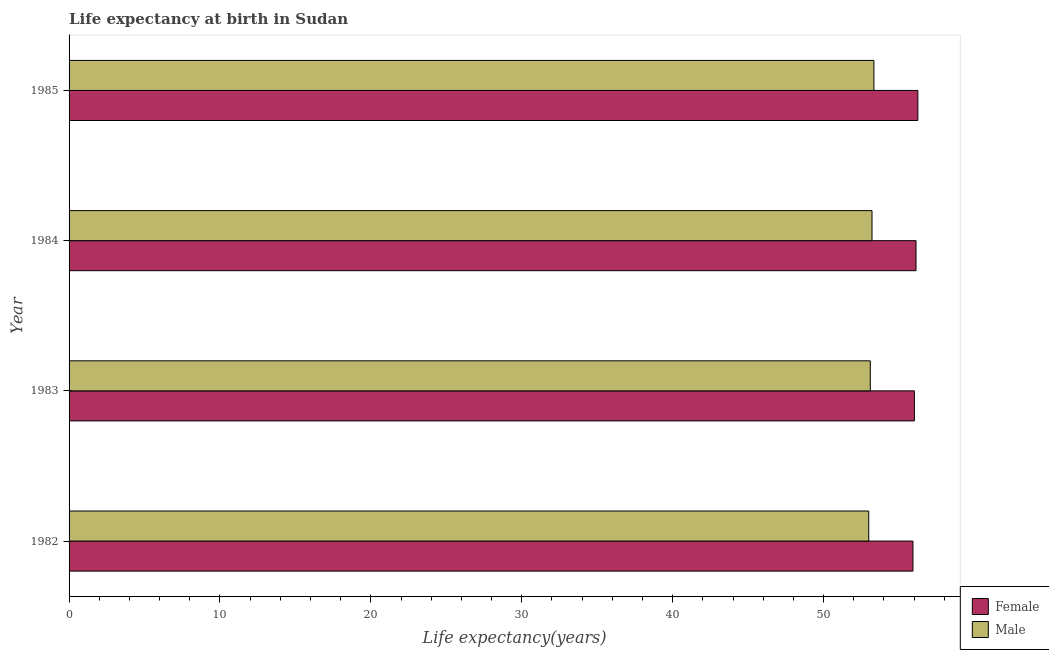Are the number of bars per tick equal to the number of legend labels?
Give a very brief answer. Yes. Are the number of bars on each tick of the Y-axis equal?
Provide a succinct answer. Yes. How many bars are there on the 3rd tick from the bottom?
Your response must be concise. 2. What is the life expectancy(female) in 1985?
Your response must be concise. 56.25. Across all years, what is the maximum life expectancy(male)?
Offer a very short reply. 53.34. Across all years, what is the minimum life expectancy(male)?
Offer a very short reply. 53. What is the total life expectancy(male) in the graph?
Offer a very short reply. 212.65. What is the difference between the life expectancy(male) in 1982 and that in 1985?
Provide a succinct answer. -0.34. What is the difference between the life expectancy(male) in 1985 and the life expectancy(female) in 1982?
Your answer should be compact. -2.59. What is the average life expectancy(male) per year?
Your answer should be compact. 53.16. In the year 1985, what is the difference between the life expectancy(female) and life expectancy(male)?
Your response must be concise. 2.91. What is the ratio of the life expectancy(male) in 1984 to that in 1985?
Give a very brief answer. 1. Is the life expectancy(male) in 1982 less than that in 1983?
Ensure brevity in your answer.  Yes. What is the difference between the highest and the lowest life expectancy(male)?
Give a very brief answer. 0.34. In how many years, is the life expectancy(female) greater than the average life expectancy(female) taken over all years?
Give a very brief answer. 2. What does the 2nd bar from the bottom in 1982 represents?
Keep it short and to the point. Male. Are all the bars in the graph horizontal?
Keep it short and to the point. Yes. How many years are there in the graph?
Offer a very short reply. 4. What is the difference between two consecutive major ticks on the X-axis?
Provide a succinct answer. 10. Are the values on the major ticks of X-axis written in scientific E-notation?
Offer a very short reply. No. Does the graph contain any zero values?
Provide a succinct answer. No. How are the legend labels stacked?
Offer a very short reply. Vertical. What is the title of the graph?
Ensure brevity in your answer.  Life expectancy at birth in Sudan. What is the label or title of the X-axis?
Ensure brevity in your answer.  Life expectancy(years). What is the label or title of the Y-axis?
Offer a terse response. Year. What is the Life expectancy(years) of Female in 1982?
Your answer should be compact. 55.92. What is the Life expectancy(years) in Male in 1982?
Your answer should be very brief. 53. What is the Life expectancy(years) in Female in 1983?
Keep it short and to the point. 56.02. What is the Life expectancy(years) in Male in 1983?
Keep it short and to the point. 53.1. What is the Life expectancy(years) of Female in 1984?
Ensure brevity in your answer.  56.13. What is the Life expectancy(years) in Male in 1984?
Keep it short and to the point. 53.21. What is the Life expectancy(years) in Female in 1985?
Your response must be concise. 56.25. What is the Life expectancy(years) of Male in 1985?
Give a very brief answer. 53.34. Across all years, what is the maximum Life expectancy(years) of Female?
Make the answer very short. 56.25. Across all years, what is the maximum Life expectancy(years) of Male?
Your response must be concise. 53.34. Across all years, what is the minimum Life expectancy(years) of Female?
Offer a terse response. 55.92. Across all years, what is the minimum Life expectancy(years) of Male?
Your answer should be compact. 53. What is the total Life expectancy(years) in Female in the graph?
Ensure brevity in your answer.  224.33. What is the total Life expectancy(years) in Male in the graph?
Your response must be concise. 212.65. What is the difference between the Life expectancy(years) of Female in 1982 and that in 1983?
Your answer should be compact. -0.1. What is the difference between the Life expectancy(years) in Male in 1982 and that in 1983?
Provide a succinct answer. -0.1. What is the difference between the Life expectancy(years) of Female in 1982 and that in 1984?
Give a very brief answer. -0.2. What is the difference between the Life expectancy(years) in Male in 1982 and that in 1984?
Your answer should be very brief. -0.22. What is the difference between the Life expectancy(years) in Female in 1982 and that in 1985?
Make the answer very short. -0.33. What is the difference between the Life expectancy(years) of Male in 1982 and that in 1985?
Offer a very short reply. -0.34. What is the difference between the Life expectancy(years) in Female in 1983 and that in 1984?
Your answer should be compact. -0.11. What is the difference between the Life expectancy(years) of Male in 1983 and that in 1984?
Your response must be concise. -0.11. What is the difference between the Life expectancy(years) in Female in 1983 and that in 1985?
Your answer should be very brief. -0.23. What is the difference between the Life expectancy(years) in Male in 1983 and that in 1985?
Provide a short and direct response. -0.24. What is the difference between the Life expectancy(years) of Female in 1984 and that in 1985?
Give a very brief answer. -0.12. What is the difference between the Life expectancy(years) of Male in 1984 and that in 1985?
Your response must be concise. -0.12. What is the difference between the Life expectancy(years) in Female in 1982 and the Life expectancy(years) in Male in 1983?
Provide a succinct answer. 2.83. What is the difference between the Life expectancy(years) in Female in 1982 and the Life expectancy(years) in Male in 1984?
Give a very brief answer. 2.71. What is the difference between the Life expectancy(years) of Female in 1982 and the Life expectancy(years) of Male in 1985?
Your answer should be compact. 2.59. What is the difference between the Life expectancy(years) of Female in 1983 and the Life expectancy(years) of Male in 1984?
Provide a short and direct response. 2.81. What is the difference between the Life expectancy(years) in Female in 1983 and the Life expectancy(years) in Male in 1985?
Ensure brevity in your answer.  2.68. What is the difference between the Life expectancy(years) in Female in 1984 and the Life expectancy(years) in Male in 1985?
Give a very brief answer. 2.79. What is the average Life expectancy(years) in Female per year?
Ensure brevity in your answer.  56.08. What is the average Life expectancy(years) in Male per year?
Your answer should be very brief. 53.16. In the year 1982, what is the difference between the Life expectancy(years) of Female and Life expectancy(years) of Male?
Provide a succinct answer. 2.93. In the year 1983, what is the difference between the Life expectancy(years) in Female and Life expectancy(years) in Male?
Provide a succinct answer. 2.92. In the year 1984, what is the difference between the Life expectancy(years) of Female and Life expectancy(years) of Male?
Your answer should be very brief. 2.92. In the year 1985, what is the difference between the Life expectancy(years) of Female and Life expectancy(years) of Male?
Your answer should be very brief. 2.91. What is the ratio of the Life expectancy(years) of Female in 1982 to that in 1983?
Offer a very short reply. 1. What is the ratio of the Life expectancy(years) of Male in 1982 to that in 1984?
Ensure brevity in your answer.  1. What is the ratio of the Life expectancy(years) in Female in 1982 to that in 1985?
Give a very brief answer. 0.99. What is the ratio of the Life expectancy(years) in Male in 1983 to that in 1984?
Offer a terse response. 1. What is the ratio of the Life expectancy(years) of Male in 1983 to that in 1985?
Provide a short and direct response. 1. What is the difference between the highest and the second highest Life expectancy(years) in Female?
Make the answer very short. 0.12. What is the difference between the highest and the second highest Life expectancy(years) of Male?
Offer a very short reply. 0.12. What is the difference between the highest and the lowest Life expectancy(years) of Female?
Your response must be concise. 0.33. What is the difference between the highest and the lowest Life expectancy(years) of Male?
Offer a terse response. 0.34. 